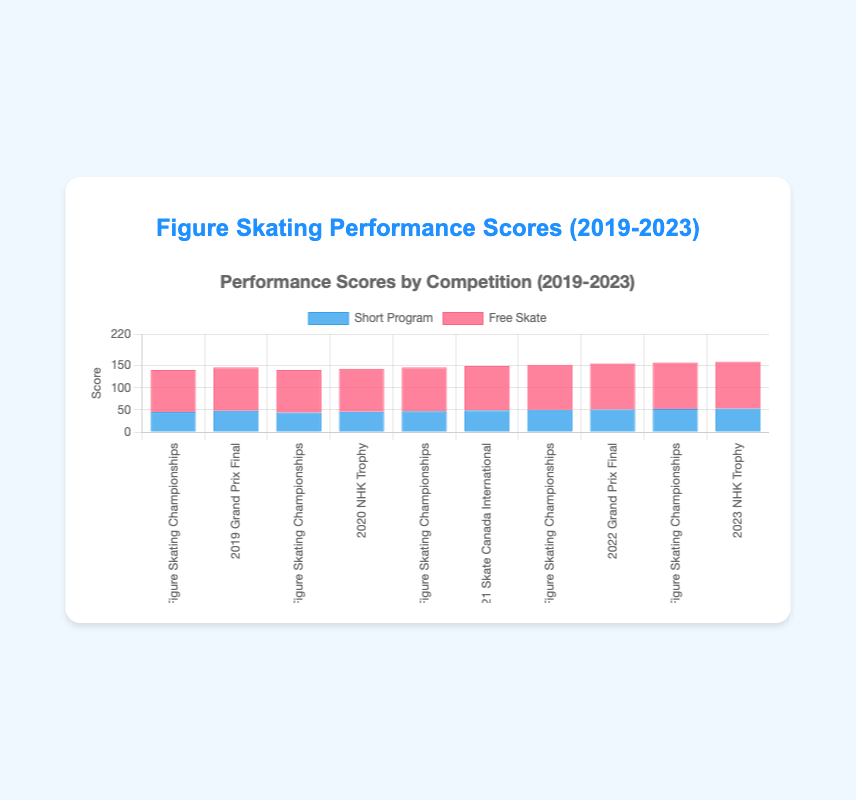Which year had the highest total score for the World Figure Skating Championships? The total scores for the World Figure Skating Championships in each year are as follows:  2019: 140, 2022: 152. Among these years, 2022 has the highest total score.
Answer: 2022 How does the Free Skate score in the Grand Prix Final of 2022 compare to that in the Grand Prix Final of 2019? The Free Skate scores for the Grand Prix Final are: 2019: 98, 2022: 104. The Free Skate score in 2022 (104) is higher than in 2019 (98).
Answer: Higher Which event had the highest Short Program score across all years? The highest Short Program scores in each event across the years are: 2019 Grand Prix Final: 48, 2020 NHK Trophy: 46, 2021 Skate Canada International: 49, 2022 Grand Prix Final: 51, 2023 NHK Trophy: 53. Among these, the 2023 NHK Trophy had the highest Short Program score of 53.
Answer: 2023 NHK Trophy What is the difference between the highest and lowest Free Skate scores in the dataset? The highest and lowest Free Skate scores in the dataset are: Highest: 2023 NHK Trophy (106), Lowest: 2019 World Figure Skating Championships (95). The difference is 106 - 95 = 11.
Answer: 11 What is the sum of the total scores for the European Figure Skating Championships and Skate Canada International in 2021? The total scores for the European Figure Skating Championships and Skate Canada International in 2021 are: 146 and 149 respectively. Their sum is 146 + 149 = 295.
Answer: 295 Which competition event shows consistent improvement in total scores from 2019 to 2023? The NHK Trophy shows consistent improvement in total scores: 2020: 143, 2023: 159. Each subsequent year shows an improvement compared to the previous years.
Answer: NHK Trophy 